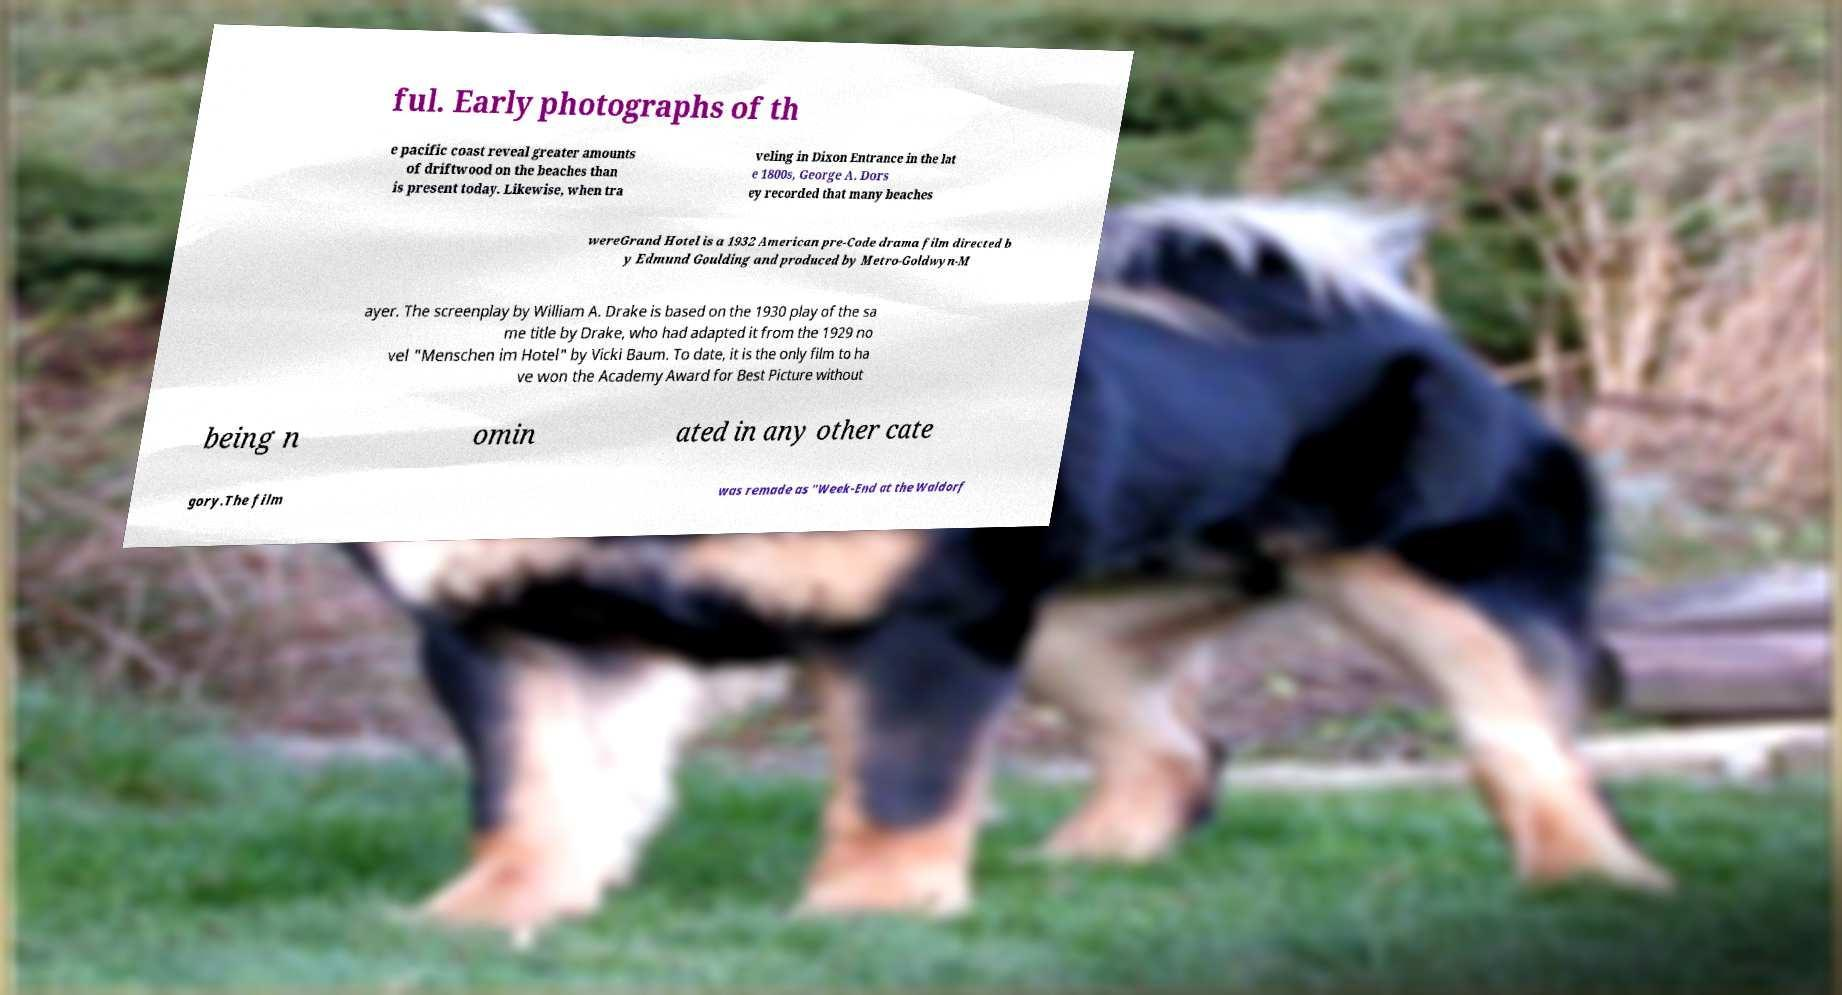I need the written content from this picture converted into text. Can you do that? ful. Early photographs of th e pacific coast reveal greater amounts of driftwood on the beaches than is present today. Likewise, when tra veling in Dixon Entrance in the lat e 1800s, George A. Dors ey recorded that many beaches wereGrand Hotel is a 1932 American pre-Code drama film directed b y Edmund Goulding and produced by Metro-Goldwyn-M ayer. The screenplay by William A. Drake is based on the 1930 play of the sa me title by Drake, who had adapted it from the 1929 no vel "Menschen im Hotel" by Vicki Baum. To date, it is the only film to ha ve won the Academy Award for Best Picture without being n omin ated in any other cate gory.The film was remade as "Week-End at the Waldorf 